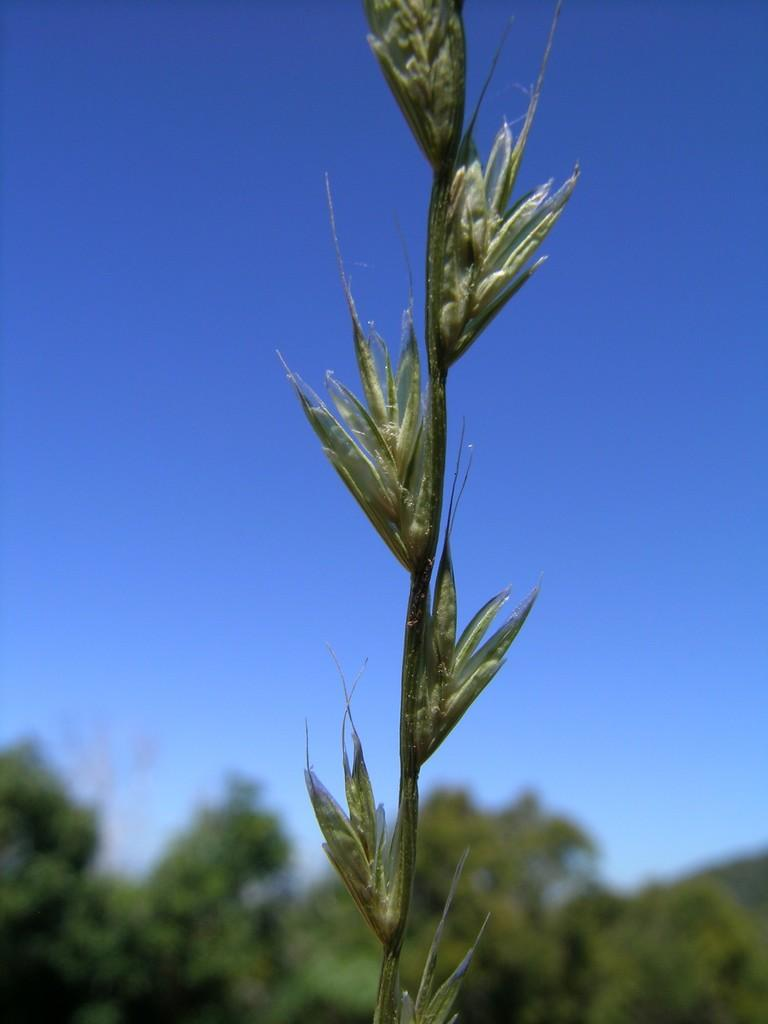What type of plant is in the picture? There is a plant in the picture, and it has buds with seeds. What can be seen in the background of the picture? There are trees in the background of the picture. What is the condition of the sky in the picture? The sky is clear in the picture. Can you tell me how many boats are visible in the picture? There are no boats present in the picture; it features a plant with buds and seeds, trees in the background, and a clear sky. What type of vessel is shown navigating through the fog in the image? There is no vessel or fog present in the image. 